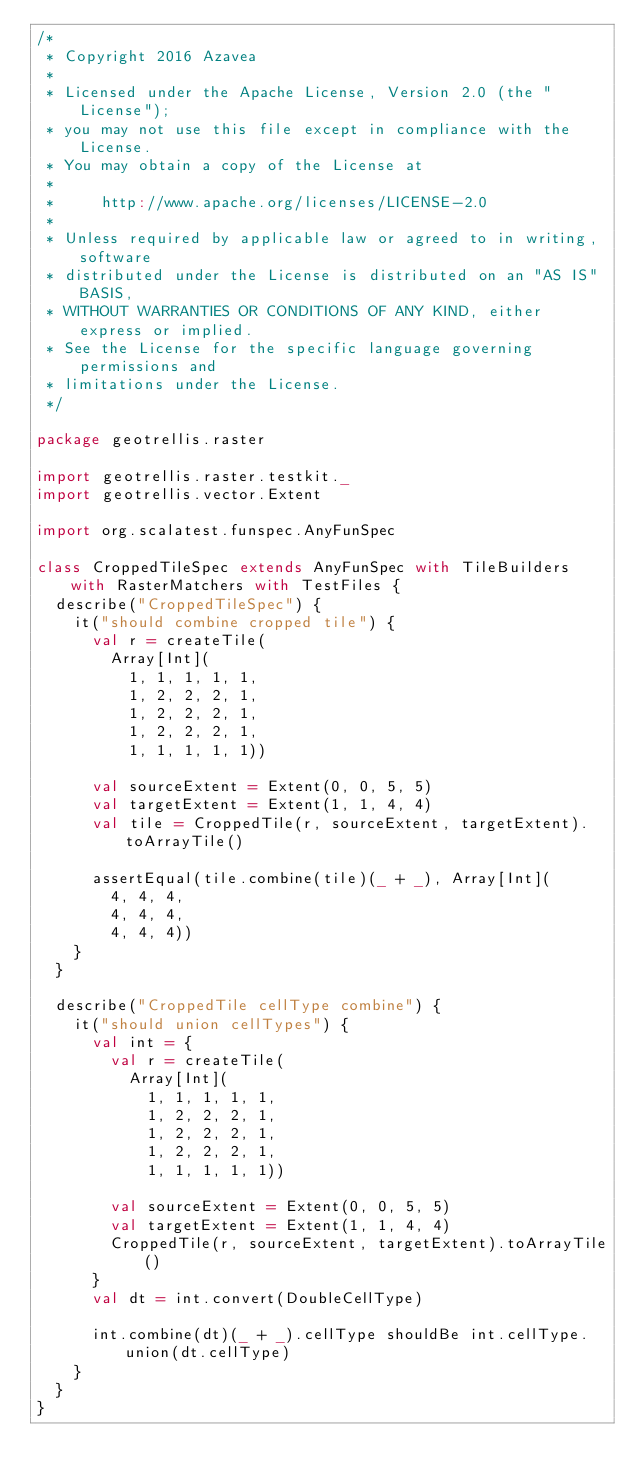Convert code to text. <code><loc_0><loc_0><loc_500><loc_500><_Scala_>/*
 * Copyright 2016 Azavea
 *
 * Licensed under the Apache License, Version 2.0 (the "License");
 * you may not use this file except in compliance with the License.
 * You may obtain a copy of the License at
 *
 *     http://www.apache.org/licenses/LICENSE-2.0
 *
 * Unless required by applicable law or agreed to in writing, software
 * distributed under the License is distributed on an "AS IS" BASIS,
 * WITHOUT WARRANTIES OR CONDITIONS OF ANY KIND, either express or implied.
 * See the License for the specific language governing permissions and
 * limitations under the License.
 */

package geotrellis.raster

import geotrellis.raster.testkit._
import geotrellis.vector.Extent

import org.scalatest.funspec.AnyFunSpec

class CroppedTileSpec extends AnyFunSpec with TileBuilders with RasterMatchers with TestFiles {
  describe("CroppedTileSpec") {
    it("should combine cropped tile") {
      val r = createTile(
        Array[Int](
          1, 1, 1, 1, 1,
          1, 2, 2, 2, 1,
          1, 2, 2, 2, 1,
          1, 2, 2, 2, 1,
          1, 1, 1, 1, 1))

      val sourceExtent = Extent(0, 0, 5, 5)
      val targetExtent = Extent(1, 1, 4, 4)
      val tile = CroppedTile(r, sourceExtent, targetExtent).toArrayTile()

      assertEqual(tile.combine(tile)(_ + _), Array[Int](
        4, 4, 4,
        4, 4, 4,
        4, 4, 4))
    }
  }

  describe("CroppedTile cellType combine") {
    it("should union cellTypes") {
      val int = {
        val r = createTile(
          Array[Int](
            1, 1, 1, 1, 1,
            1, 2, 2, 2, 1,
            1, 2, 2, 2, 1,
            1, 2, 2, 2, 1,
            1, 1, 1, 1, 1))

        val sourceExtent = Extent(0, 0, 5, 5)
        val targetExtent = Extent(1, 1, 4, 4)
        CroppedTile(r, sourceExtent, targetExtent).toArrayTile()
      }
      val dt = int.convert(DoubleCellType)

      int.combine(dt)(_ + _).cellType shouldBe int.cellType.union(dt.cellType)
    }
  }
}
</code> 